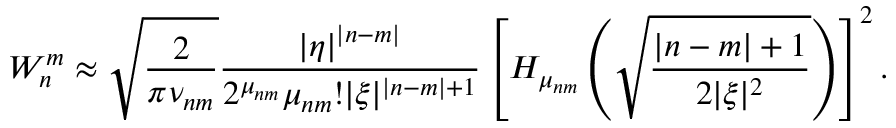Convert formula to latex. <formula><loc_0><loc_0><loc_500><loc_500>W _ { n } ^ { m } \approx \sqrt { \frac { 2 } \pi \nu _ { n m } } } \frac { | \eta | ^ { | n - m | } } { 2 ^ { \mu _ { n m } } \mu _ { n m } ! | \xi | ^ { | n - m | + 1 } } \left [ H _ { \mu _ { n m } } \left ( \sqrt { \frac { | n - m | + 1 } { 2 | \xi | ^ { 2 } } } \right ) \right ] ^ { 2 } .</formula> 